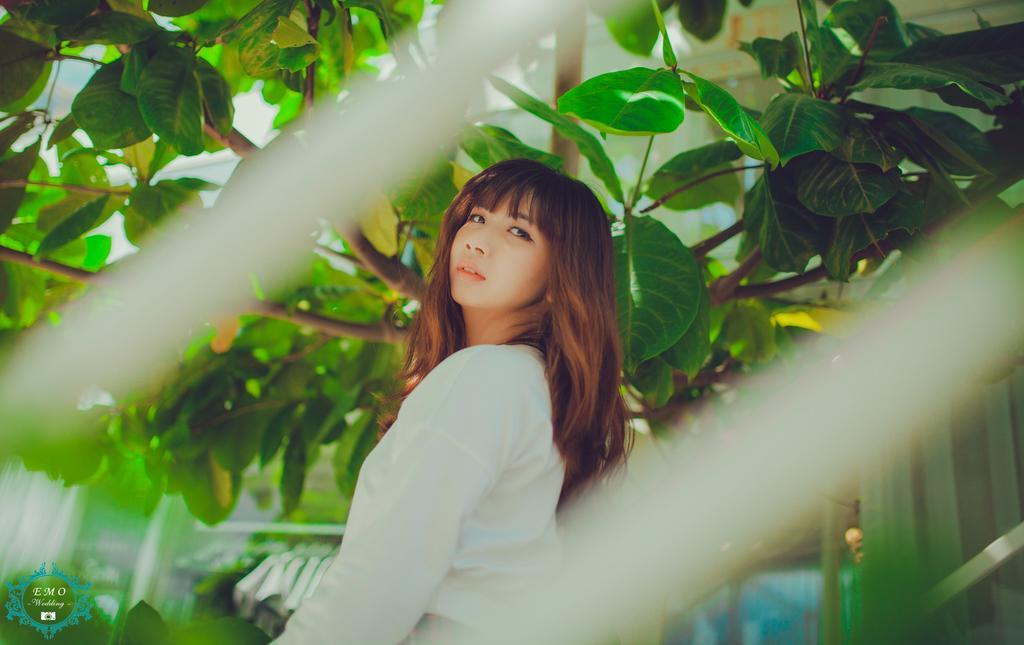Could you give a brief overview of what you see in this image? In this image, in the middle we can see a girl standing. We can see some branches and some green leaves. 